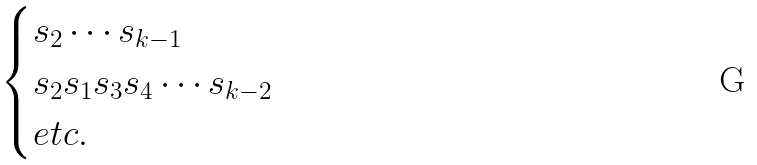Convert formula to latex. <formula><loc_0><loc_0><loc_500><loc_500>\begin{cases} s _ { 2 } \cdots s _ { k - 1 } \\ s _ { 2 } s _ { 1 } s _ { 3 } s _ { 4 } \cdots s _ { k - 2 } \\ e t c . \end{cases}</formula> 